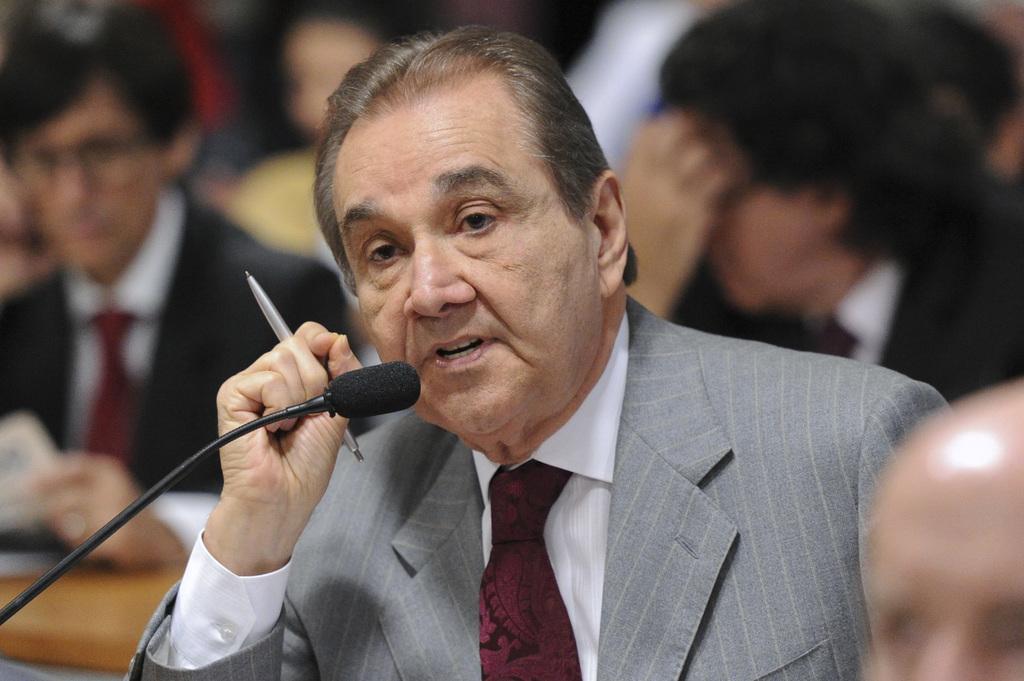How would you summarize this image in a sentence or two? In this picture we can see a man in the blazer is holding a pen and explaining something. In front of the man there is the microphone. Behind the man there are blurred people. 